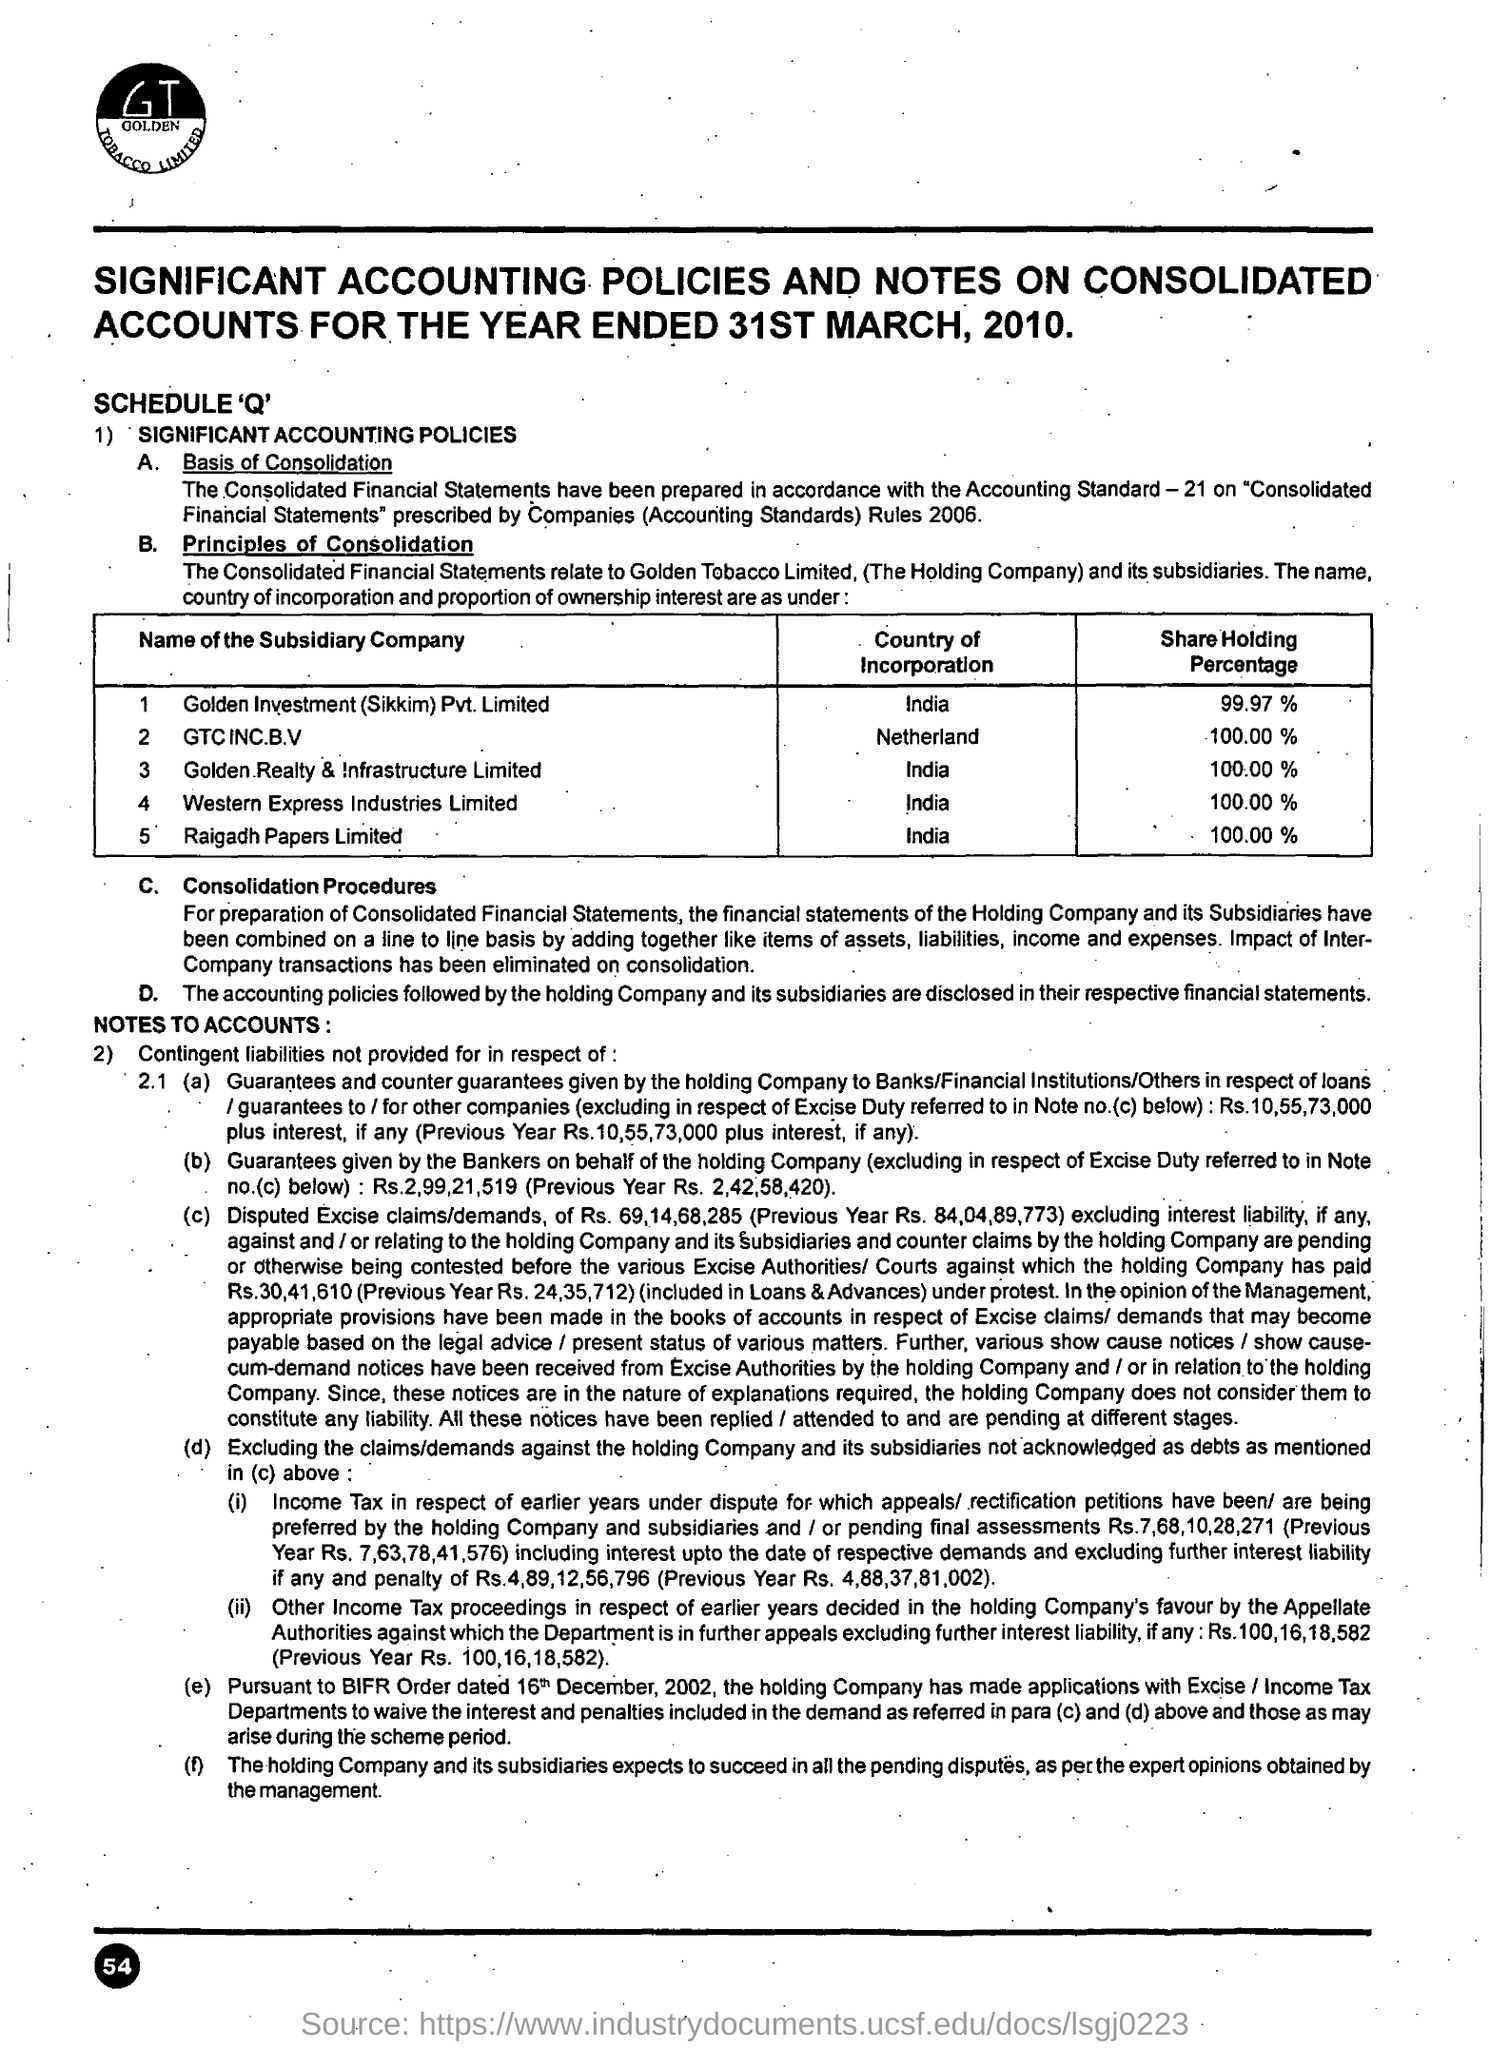Which country is incorporated with Raigadh Papers Limited?
Provide a succinct answer. India. Find Share holding percentage of GTC INC B.V
Give a very brief answer. 100.00%. Which country is incorporated with GTC INC B.V?
Offer a very short reply. Netherland. 